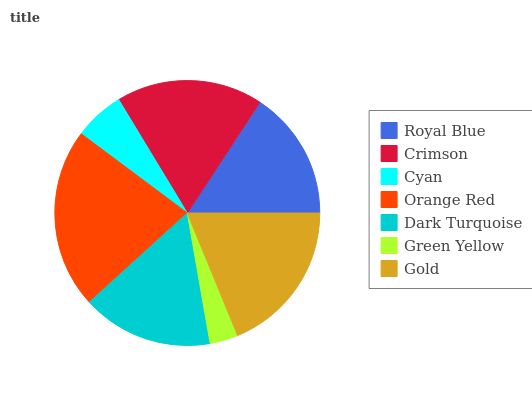Is Green Yellow the minimum?
Answer yes or no. Yes. Is Orange Red the maximum?
Answer yes or no. Yes. Is Crimson the minimum?
Answer yes or no. No. Is Crimson the maximum?
Answer yes or no. No. Is Crimson greater than Royal Blue?
Answer yes or no. Yes. Is Royal Blue less than Crimson?
Answer yes or no. Yes. Is Royal Blue greater than Crimson?
Answer yes or no. No. Is Crimson less than Royal Blue?
Answer yes or no. No. Is Dark Turquoise the high median?
Answer yes or no. Yes. Is Dark Turquoise the low median?
Answer yes or no. Yes. Is Orange Red the high median?
Answer yes or no. No. Is Orange Red the low median?
Answer yes or no. No. 